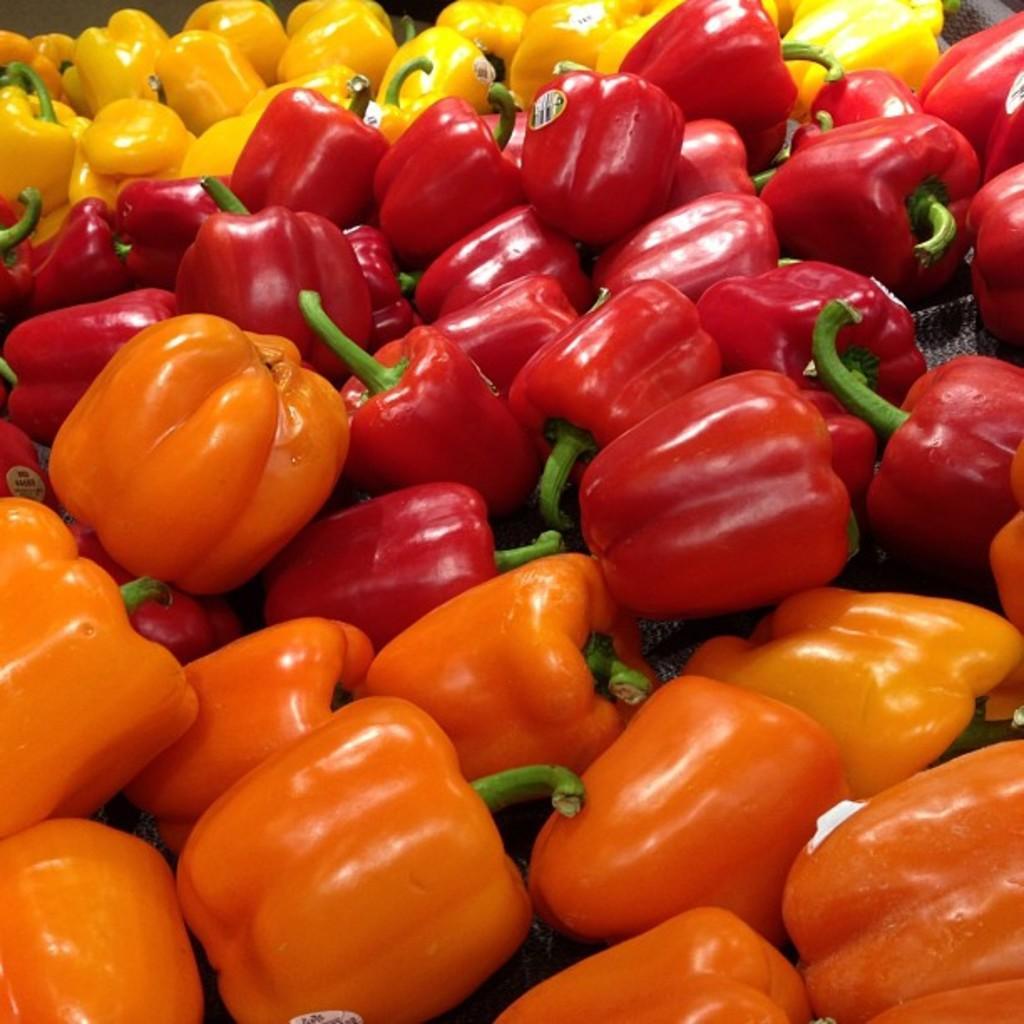Please provide a concise description of this image. In this image I can see number of capsicum which are yellow, red, green and orange in color and I can see few stickers attached to them. 